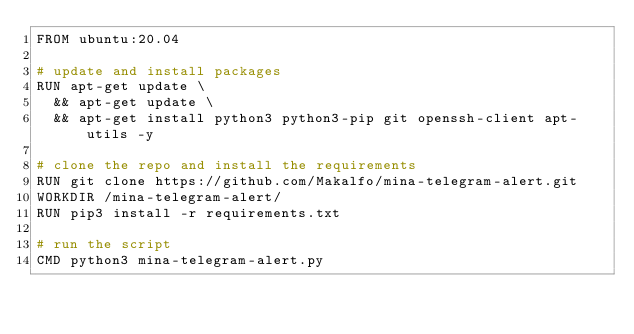Convert code to text. <code><loc_0><loc_0><loc_500><loc_500><_Dockerfile_>FROM ubuntu:20.04

# update and install packages
RUN apt-get update \
  && apt-get update \
  && apt-get install python3 python3-pip git openssh-client apt-utils -y

# clone the repo and install the requirements
RUN git clone https://github.com/Makalfo/mina-telegram-alert.git
WORKDIR /mina-telegram-alert/
RUN pip3 install -r requirements.txt

# run the script
CMD python3 mina-telegram-alert.py</code> 